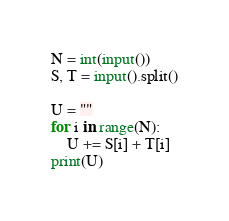<code> <loc_0><loc_0><loc_500><loc_500><_Python_>N = int(input())
S, T = input().split()

U = ""
for i in range(N):
    U += S[i] + T[i]
print(U)
</code> 